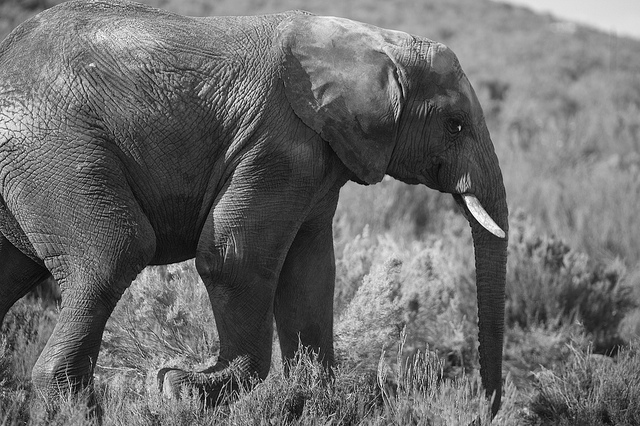<image>What kind of enclosure is the elephant in? It is ambiguous what kind of enclosure the elephant is in. It could be a zoo or a field. What kind of enclosure is the elephant in? The elephant is in a zoo enclosure. 